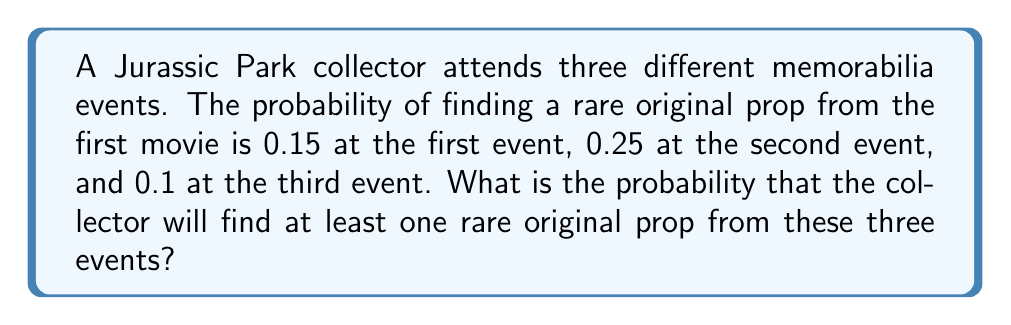Could you help me with this problem? Let's approach this step-by-step:

1) First, we need to calculate the probability of not finding a rare prop at each event:
   Event 1: $1 - 0.15 = 0.85$
   Event 2: $1 - 0.25 = 0.75$
   Event 3: $1 - 0.1 = 0.9$

2) The probability of not finding a rare prop at any of the three events is the product of these probabilities:
   $P(\text{no rare prop}) = 0.85 \times 0.75 \times 0.9 = 0.57375$

3) Therefore, the probability of finding at least one rare prop is the complement of this probability:
   $P(\text{at least one rare prop}) = 1 - P(\text{no rare prop})$
   $= 1 - 0.57375 = 0.42625$

4) We can express this as a percentage:
   $0.42625 \times 100\% = 42.625\%$

Thus, the probability of finding at least one rare original prop from the first Jurassic Park movie across these three events is approximately 42.63%.
Answer: $42.63\%$ 